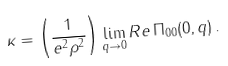<formula> <loc_0><loc_0><loc_500><loc_500>\kappa = \left ( \frac { 1 } { e ^ { 2 } \rho ^ { 2 } } \right ) \lim _ { { q } \rightarrow 0 } R e \, \Pi _ { 0 0 } ( 0 , { q } ) \, .</formula> 